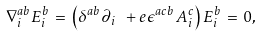<formula> <loc_0><loc_0><loc_500><loc_500>\nabla ^ { a b } _ { i } E ^ { b } _ { i } \, = \, \left ( \delta ^ { a b } \partial _ { i } \ + e \epsilon ^ { a c b } \, A ^ { c } _ { i } \right ) E ^ { b } _ { i } \, = \, 0 ,</formula> 